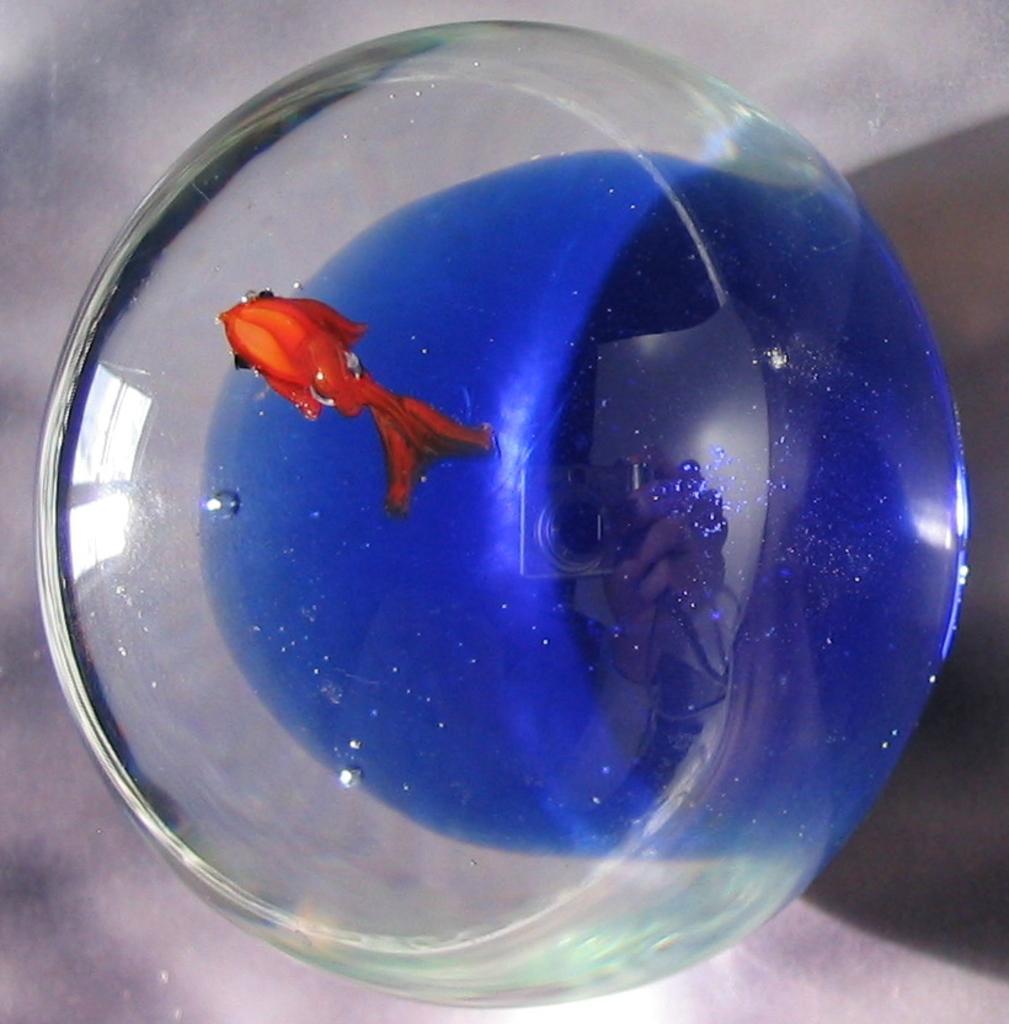In one or two sentences, can you explain what this image depicts? In this image there is an aquarium on an object, there is water in the aquarium, there is water in the aquarium, there is a fish in the water, the background of the image is white in color. 